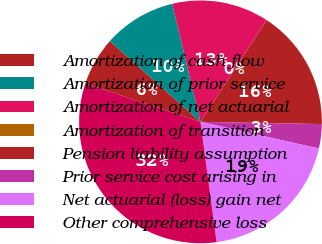<chart> <loc_0><loc_0><loc_500><loc_500><pie_chart><fcel>Amortization of cash flow<fcel>Amortization of prior service<fcel>Amortization of net actuarial<fcel>Amortization of transition<fcel>Pension liability assumption<fcel>Prior service cost arising in<fcel>Net actuarial (loss) gain net<fcel>Other comprehensive loss<nl><fcel>6.46%<fcel>9.68%<fcel>12.9%<fcel>0.01%<fcel>16.12%<fcel>3.24%<fcel>19.35%<fcel>32.24%<nl></chart> 